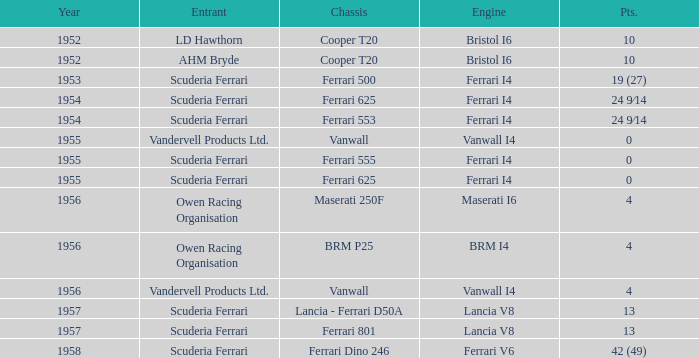Which participant has 4 points and brm p25 for the chassis? Owen Racing Organisation. 